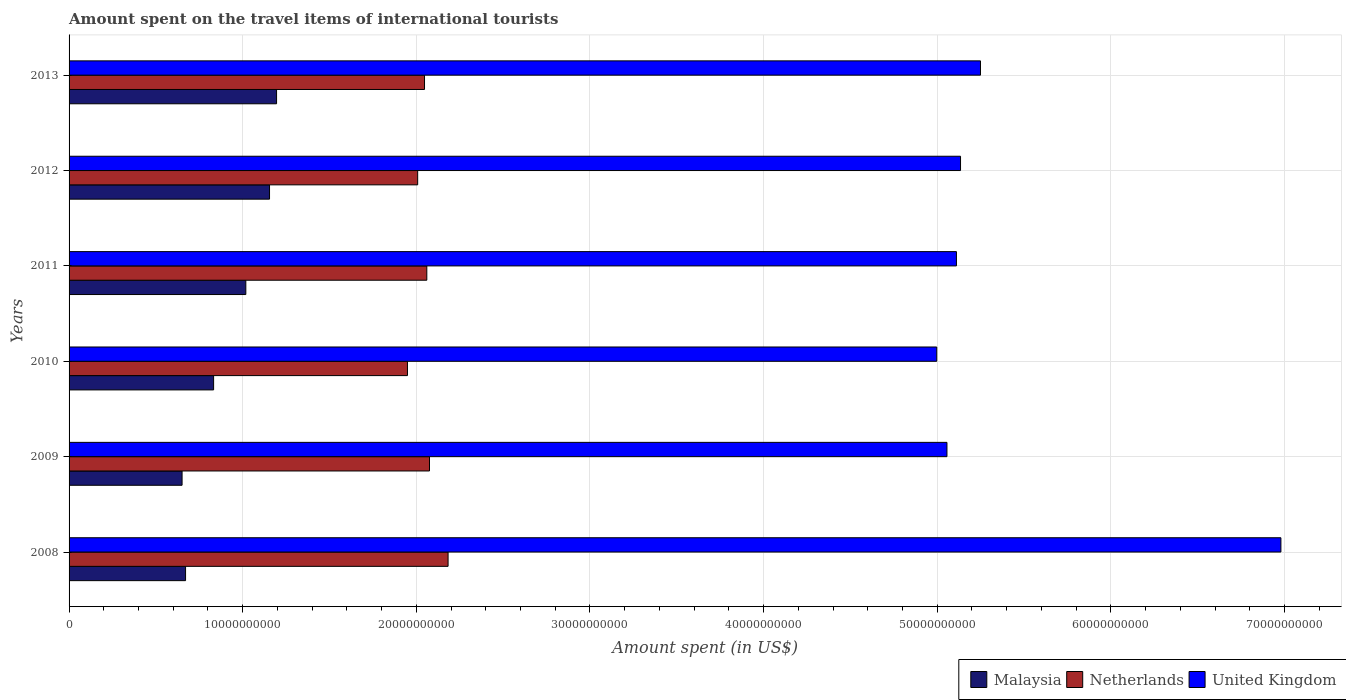How many different coloured bars are there?
Offer a terse response. 3. How many groups of bars are there?
Give a very brief answer. 6. Are the number of bars per tick equal to the number of legend labels?
Provide a succinct answer. Yes. How many bars are there on the 2nd tick from the top?
Your answer should be compact. 3. How many bars are there on the 2nd tick from the bottom?
Keep it short and to the point. 3. In how many cases, is the number of bars for a given year not equal to the number of legend labels?
Your response must be concise. 0. What is the amount spent on the travel items of international tourists in United Kingdom in 2010?
Provide a short and direct response. 5.00e+1. Across all years, what is the maximum amount spent on the travel items of international tourists in Netherlands?
Your response must be concise. 2.18e+1. Across all years, what is the minimum amount spent on the travel items of international tourists in United Kingdom?
Provide a succinct answer. 5.00e+1. What is the total amount spent on the travel items of international tourists in United Kingdom in the graph?
Provide a short and direct response. 3.25e+11. What is the difference between the amount spent on the travel items of international tourists in Netherlands in 2011 and that in 2013?
Offer a terse response. 1.32e+08. What is the difference between the amount spent on the travel items of international tourists in United Kingdom in 2011 and the amount spent on the travel items of international tourists in Netherlands in 2013?
Keep it short and to the point. 3.06e+1. What is the average amount spent on the travel items of international tourists in Netherlands per year?
Keep it short and to the point. 2.05e+1. In the year 2008, what is the difference between the amount spent on the travel items of international tourists in Netherlands and amount spent on the travel items of international tourists in United Kingdom?
Provide a short and direct response. -4.80e+1. What is the ratio of the amount spent on the travel items of international tourists in Malaysia in 2008 to that in 2010?
Your answer should be very brief. 0.81. What is the difference between the highest and the second highest amount spent on the travel items of international tourists in Malaysia?
Provide a short and direct response. 4.05e+08. What is the difference between the highest and the lowest amount spent on the travel items of international tourists in United Kingdom?
Ensure brevity in your answer.  1.98e+1. Is the sum of the amount spent on the travel items of international tourists in United Kingdom in 2009 and 2010 greater than the maximum amount spent on the travel items of international tourists in Malaysia across all years?
Ensure brevity in your answer.  Yes. How many bars are there?
Provide a succinct answer. 18. Does the graph contain any zero values?
Ensure brevity in your answer.  No. What is the title of the graph?
Your answer should be very brief. Amount spent on the travel items of international tourists. Does "Botswana" appear as one of the legend labels in the graph?
Provide a short and direct response. No. What is the label or title of the X-axis?
Your response must be concise. Amount spent (in US$). What is the Amount spent (in US$) of Malaysia in 2008?
Offer a very short reply. 6.71e+09. What is the Amount spent (in US$) of Netherlands in 2008?
Offer a very short reply. 2.18e+1. What is the Amount spent (in US$) in United Kingdom in 2008?
Make the answer very short. 6.98e+1. What is the Amount spent (in US$) of Malaysia in 2009?
Ensure brevity in your answer.  6.51e+09. What is the Amount spent (in US$) in Netherlands in 2009?
Ensure brevity in your answer.  2.08e+1. What is the Amount spent (in US$) of United Kingdom in 2009?
Give a very brief answer. 5.06e+1. What is the Amount spent (in US$) of Malaysia in 2010?
Your answer should be compact. 8.32e+09. What is the Amount spent (in US$) of Netherlands in 2010?
Your answer should be compact. 1.95e+1. What is the Amount spent (in US$) of United Kingdom in 2010?
Provide a succinct answer. 5.00e+1. What is the Amount spent (in US$) in Malaysia in 2011?
Ensure brevity in your answer.  1.02e+1. What is the Amount spent (in US$) in Netherlands in 2011?
Your response must be concise. 2.06e+1. What is the Amount spent (in US$) of United Kingdom in 2011?
Your response must be concise. 5.11e+1. What is the Amount spent (in US$) of Malaysia in 2012?
Give a very brief answer. 1.15e+1. What is the Amount spent (in US$) of Netherlands in 2012?
Your response must be concise. 2.01e+1. What is the Amount spent (in US$) of United Kingdom in 2012?
Offer a terse response. 5.13e+1. What is the Amount spent (in US$) of Malaysia in 2013?
Offer a terse response. 1.20e+1. What is the Amount spent (in US$) in Netherlands in 2013?
Ensure brevity in your answer.  2.05e+1. What is the Amount spent (in US$) in United Kingdom in 2013?
Offer a terse response. 5.25e+1. Across all years, what is the maximum Amount spent (in US$) in Malaysia?
Your answer should be very brief. 1.20e+1. Across all years, what is the maximum Amount spent (in US$) of Netherlands?
Your response must be concise. 2.18e+1. Across all years, what is the maximum Amount spent (in US$) of United Kingdom?
Your answer should be very brief. 6.98e+1. Across all years, what is the minimum Amount spent (in US$) in Malaysia?
Give a very brief answer. 6.51e+09. Across all years, what is the minimum Amount spent (in US$) in Netherlands?
Offer a very short reply. 1.95e+1. Across all years, what is the minimum Amount spent (in US$) in United Kingdom?
Your response must be concise. 5.00e+1. What is the total Amount spent (in US$) in Malaysia in the graph?
Offer a very short reply. 5.52e+1. What is the total Amount spent (in US$) of Netherlands in the graph?
Your answer should be compact. 1.23e+11. What is the total Amount spent (in US$) of United Kingdom in the graph?
Keep it short and to the point. 3.25e+11. What is the difference between the Amount spent (in US$) in Malaysia in 2008 and that in 2009?
Your answer should be compact. 2.01e+08. What is the difference between the Amount spent (in US$) of Netherlands in 2008 and that in 2009?
Provide a succinct answer. 1.07e+09. What is the difference between the Amount spent (in US$) in United Kingdom in 2008 and that in 2009?
Provide a short and direct response. 1.92e+1. What is the difference between the Amount spent (in US$) in Malaysia in 2008 and that in 2010?
Offer a terse response. -1.62e+09. What is the difference between the Amount spent (in US$) of Netherlands in 2008 and that in 2010?
Keep it short and to the point. 2.34e+09. What is the difference between the Amount spent (in US$) in United Kingdom in 2008 and that in 2010?
Provide a succinct answer. 1.98e+1. What is the difference between the Amount spent (in US$) in Malaysia in 2008 and that in 2011?
Offer a terse response. -3.47e+09. What is the difference between the Amount spent (in US$) of Netherlands in 2008 and that in 2011?
Give a very brief answer. 1.22e+09. What is the difference between the Amount spent (in US$) of United Kingdom in 2008 and that in 2011?
Give a very brief answer. 1.87e+1. What is the difference between the Amount spent (in US$) of Malaysia in 2008 and that in 2012?
Offer a very short reply. -4.84e+09. What is the difference between the Amount spent (in US$) in Netherlands in 2008 and that in 2012?
Offer a terse response. 1.75e+09. What is the difference between the Amount spent (in US$) of United Kingdom in 2008 and that in 2012?
Keep it short and to the point. 1.85e+1. What is the difference between the Amount spent (in US$) in Malaysia in 2008 and that in 2013?
Keep it short and to the point. -5.24e+09. What is the difference between the Amount spent (in US$) in Netherlands in 2008 and that in 2013?
Make the answer very short. 1.36e+09. What is the difference between the Amount spent (in US$) of United Kingdom in 2008 and that in 2013?
Offer a very short reply. 1.73e+1. What is the difference between the Amount spent (in US$) in Malaysia in 2009 and that in 2010?
Ensure brevity in your answer.  -1.82e+09. What is the difference between the Amount spent (in US$) of Netherlands in 2009 and that in 2010?
Provide a succinct answer. 1.27e+09. What is the difference between the Amount spent (in US$) in United Kingdom in 2009 and that in 2010?
Ensure brevity in your answer.  5.87e+08. What is the difference between the Amount spent (in US$) in Malaysia in 2009 and that in 2011?
Give a very brief answer. -3.67e+09. What is the difference between the Amount spent (in US$) of Netherlands in 2009 and that in 2011?
Offer a terse response. 1.55e+08. What is the difference between the Amount spent (in US$) of United Kingdom in 2009 and that in 2011?
Provide a short and direct response. -5.46e+08. What is the difference between the Amount spent (in US$) of Malaysia in 2009 and that in 2012?
Your answer should be very brief. -5.04e+09. What is the difference between the Amount spent (in US$) in Netherlands in 2009 and that in 2012?
Provide a succinct answer. 6.81e+08. What is the difference between the Amount spent (in US$) of United Kingdom in 2009 and that in 2012?
Provide a short and direct response. -7.82e+08. What is the difference between the Amount spent (in US$) of Malaysia in 2009 and that in 2013?
Your answer should be compact. -5.44e+09. What is the difference between the Amount spent (in US$) in Netherlands in 2009 and that in 2013?
Provide a short and direct response. 2.87e+08. What is the difference between the Amount spent (in US$) of United Kingdom in 2009 and that in 2013?
Your answer should be compact. -1.93e+09. What is the difference between the Amount spent (in US$) in Malaysia in 2010 and that in 2011?
Make the answer very short. -1.86e+09. What is the difference between the Amount spent (in US$) in Netherlands in 2010 and that in 2011?
Ensure brevity in your answer.  -1.11e+09. What is the difference between the Amount spent (in US$) in United Kingdom in 2010 and that in 2011?
Provide a short and direct response. -1.13e+09. What is the difference between the Amount spent (in US$) of Malaysia in 2010 and that in 2012?
Give a very brief answer. -3.22e+09. What is the difference between the Amount spent (in US$) in Netherlands in 2010 and that in 2012?
Your answer should be very brief. -5.88e+08. What is the difference between the Amount spent (in US$) of United Kingdom in 2010 and that in 2012?
Your answer should be compact. -1.37e+09. What is the difference between the Amount spent (in US$) in Malaysia in 2010 and that in 2013?
Give a very brief answer. -3.63e+09. What is the difference between the Amount spent (in US$) of Netherlands in 2010 and that in 2013?
Make the answer very short. -9.82e+08. What is the difference between the Amount spent (in US$) in United Kingdom in 2010 and that in 2013?
Make the answer very short. -2.52e+09. What is the difference between the Amount spent (in US$) in Malaysia in 2011 and that in 2012?
Provide a succinct answer. -1.36e+09. What is the difference between the Amount spent (in US$) of Netherlands in 2011 and that in 2012?
Provide a succinct answer. 5.26e+08. What is the difference between the Amount spent (in US$) of United Kingdom in 2011 and that in 2012?
Make the answer very short. -2.36e+08. What is the difference between the Amount spent (in US$) in Malaysia in 2011 and that in 2013?
Provide a succinct answer. -1.77e+09. What is the difference between the Amount spent (in US$) of Netherlands in 2011 and that in 2013?
Ensure brevity in your answer.  1.32e+08. What is the difference between the Amount spent (in US$) in United Kingdom in 2011 and that in 2013?
Your response must be concise. -1.38e+09. What is the difference between the Amount spent (in US$) in Malaysia in 2012 and that in 2013?
Keep it short and to the point. -4.05e+08. What is the difference between the Amount spent (in US$) in Netherlands in 2012 and that in 2013?
Offer a terse response. -3.94e+08. What is the difference between the Amount spent (in US$) in United Kingdom in 2012 and that in 2013?
Offer a very short reply. -1.15e+09. What is the difference between the Amount spent (in US$) of Malaysia in 2008 and the Amount spent (in US$) of Netherlands in 2009?
Ensure brevity in your answer.  -1.40e+1. What is the difference between the Amount spent (in US$) in Malaysia in 2008 and the Amount spent (in US$) in United Kingdom in 2009?
Offer a very short reply. -4.38e+1. What is the difference between the Amount spent (in US$) in Netherlands in 2008 and the Amount spent (in US$) in United Kingdom in 2009?
Give a very brief answer. -2.87e+1. What is the difference between the Amount spent (in US$) of Malaysia in 2008 and the Amount spent (in US$) of Netherlands in 2010?
Make the answer very short. -1.28e+1. What is the difference between the Amount spent (in US$) in Malaysia in 2008 and the Amount spent (in US$) in United Kingdom in 2010?
Your response must be concise. -4.33e+1. What is the difference between the Amount spent (in US$) of Netherlands in 2008 and the Amount spent (in US$) of United Kingdom in 2010?
Ensure brevity in your answer.  -2.81e+1. What is the difference between the Amount spent (in US$) of Malaysia in 2008 and the Amount spent (in US$) of Netherlands in 2011?
Your answer should be compact. -1.39e+1. What is the difference between the Amount spent (in US$) of Malaysia in 2008 and the Amount spent (in US$) of United Kingdom in 2011?
Your answer should be very brief. -4.44e+1. What is the difference between the Amount spent (in US$) of Netherlands in 2008 and the Amount spent (in US$) of United Kingdom in 2011?
Your answer should be compact. -2.93e+1. What is the difference between the Amount spent (in US$) of Malaysia in 2008 and the Amount spent (in US$) of Netherlands in 2012?
Your answer should be compact. -1.34e+1. What is the difference between the Amount spent (in US$) in Malaysia in 2008 and the Amount spent (in US$) in United Kingdom in 2012?
Make the answer very short. -4.46e+1. What is the difference between the Amount spent (in US$) in Netherlands in 2008 and the Amount spent (in US$) in United Kingdom in 2012?
Offer a very short reply. -2.95e+1. What is the difference between the Amount spent (in US$) of Malaysia in 2008 and the Amount spent (in US$) of Netherlands in 2013?
Your answer should be very brief. -1.38e+1. What is the difference between the Amount spent (in US$) in Malaysia in 2008 and the Amount spent (in US$) in United Kingdom in 2013?
Give a very brief answer. -4.58e+1. What is the difference between the Amount spent (in US$) in Netherlands in 2008 and the Amount spent (in US$) in United Kingdom in 2013?
Offer a very short reply. -3.07e+1. What is the difference between the Amount spent (in US$) of Malaysia in 2009 and the Amount spent (in US$) of Netherlands in 2010?
Offer a terse response. -1.30e+1. What is the difference between the Amount spent (in US$) in Malaysia in 2009 and the Amount spent (in US$) in United Kingdom in 2010?
Provide a short and direct response. -4.35e+1. What is the difference between the Amount spent (in US$) in Netherlands in 2009 and the Amount spent (in US$) in United Kingdom in 2010?
Offer a very short reply. -2.92e+1. What is the difference between the Amount spent (in US$) in Malaysia in 2009 and the Amount spent (in US$) in Netherlands in 2011?
Give a very brief answer. -1.41e+1. What is the difference between the Amount spent (in US$) of Malaysia in 2009 and the Amount spent (in US$) of United Kingdom in 2011?
Your answer should be very brief. -4.46e+1. What is the difference between the Amount spent (in US$) of Netherlands in 2009 and the Amount spent (in US$) of United Kingdom in 2011?
Your answer should be compact. -3.03e+1. What is the difference between the Amount spent (in US$) of Malaysia in 2009 and the Amount spent (in US$) of Netherlands in 2012?
Offer a very short reply. -1.36e+1. What is the difference between the Amount spent (in US$) of Malaysia in 2009 and the Amount spent (in US$) of United Kingdom in 2012?
Ensure brevity in your answer.  -4.48e+1. What is the difference between the Amount spent (in US$) in Netherlands in 2009 and the Amount spent (in US$) in United Kingdom in 2012?
Offer a very short reply. -3.06e+1. What is the difference between the Amount spent (in US$) of Malaysia in 2009 and the Amount spent (in US$) of Netherlands in 2013?
Your answer should be compact. -1.40e+1. What is the difference between the Amount spent (in US$) in Malaysia in 2009 and the Amount spent (in US$) in United Kingdom in 2013?
Your answer should be very brief. -4.60e+1. What is the difference between the Amount spent (in US$) in Netherlands in 2009 and the Amount spent (in US$) in United Kingdom in 2013?
Your response must be concise. -3.17e+1. What is the difference between the Amount spent (in US$) in Malaysia in 2010 and the Amount spent (in US$) in Netherlands in 2011?
Keep it short and to the point. -1.23e+1. What is the difference between the Amount spent (in US$) in Malaysia in 2010 and the Amount spent (in US$) in United Kingdom in 2011?
Provide a short and direct response. -4.28e+1. What is the difference between the Amount spent (in US$) of Netherlands in 2010 and the Amount spent (in US$) of United Kingdom in 2011?
Ensure brevity in your answer.  -3.16e+1. What is the difference between the Amount spent (in US$) in Malaysia in 2010 and the Amount spent (in US$) in Netherlands in 2012?
Make the answer very short. -1.18e+1. What is the difference between the Amount spent (in US$) in Malaysia in 2010 and the Amount spent (in US$) in United Kingdom in 2012?
Ensure brevity in your answer.  -4.30e+1. What is the difference between the Amount spent (in US$) in Netherlands in 2010 and the Amount spent (in US$) in United Kingdom in 2012?
Provide a short and direct response. -3.19e+1. What is the difference between the Amount spent (in US$) of Malaysia in 2010 and the Amount spent (in US$) of Netherlands in 2013?
Provide a short and direct response. -1.21e+1. What is the difference between the Amount spent (in US$) of Malaysia in 2010 and the Amount spent (in US$) of United Kingdom in 2013?
Make the answer very short. -4.42e+1. What is the difference between the Amount spent (in US$) of Netherlands in 2010 and the Amount spent (in US$) of United Kingdom in 2013?
Your response must be concise. -3.30e+1. What is the difference between the Amount spent (in US$) in Malaysia in 2011 and the Amount spent (in US$) in Netherlands in 2012?
Provide a short and direct response. -9.90e+09. What is the difference between the Amount spent (in US$) in Malaysia in 2011 and the Amount spent (in US$) in United Kingdom in 2012?
Give a very brief answer. -4.12e+1. What is the difference between the Amount spent (in US$) of Netherlands in 2011 and the Amount spent (in US$) of United Kingdom in 2012?
Keep it short and to the point. -3.07e+1. What is the difference between the Amount spent (in US$) of Malaysia in 2011 and the Amount spent (in US$) of Netherlands in 2013?
Offer a terse response. -1.03e+1. What is the difference between the Amount spent (in US$) in Malaysia in 2011 and the Amount spent (in US$) in United Kingdom in 2013?
Your answer should be compact. -4.23e+1. What is the difference between the Amount spent (in US$) of Netherlands in 2011 and the Amount spent (in US$) of United Kingdom in 2013?
Provide a succinct answer. -3.19e+1. What is the difference between the Amount spent (in US$) in Malaysia in 2012 and the Amount spent (in US$) in Netherlands in 2013?
Ensure brevity in your answer.  -8.93e+09. What is the difference between the Amount spent (in US$) in Malaysia in 2012 and the Amount spent (in US$) in United Kingdom in 2013?
Your response must be concise. -4.09e+1. What is the difference between the Amount spent (in US$) of Netherlands in 2012 and the Amount spent (in US$) of United Kingdom in 2013?
Your answer should be very brief. -3.24e+1. What is the average Amount spent (in US$) of Malaysia per year?
Keep it short and to the point. 9.20e+09. What is the average Amount spent (in US$) in Netherlands per year?
Give a very brief answer. 2.05e+1. What is the average Amount spent (in US$) in United Kingdom per year?
Give a very brief answer. 5.42e+1. In the year 2008, what is the difference between the Amount spent (in US$) in Malaysia and Amount spent (in US$) in Netherlands?
Make the answer very short. -1.51e+1. In the year 2008, what is the difference between the Amount spent (in US$) in Malaysia and Amount spent (in US$) in United Kingdom?
Offer a very short reply. -6.31e+1. In the year 2008, what is the difference between the Amount spent (in US$) of Netherlands and Amount spent (in US$) of United Kingdom?
Make the answer very short. -4.80e+1. In the year 2009, what is the difference between the Amount spent (in US$) in Malaysia and Amount spent (in US$) in Netherlands?
Give a very brief answer. -1.42e+1. In the year 2009, what is the difference between the Amount spent (in US$) of Malaysia and Amount spent (in US$) of United Kingdom?
Ensure brevity in your answer.  -4.41e+1. In the year 2009, what is the difference between the Amount spent (in US$) in Netherlands and Amount spent (in US$) in United Kingdom?
Give a very brief answer. -2.98e+1. In the year 2010, what is the difference between the Amount spent (in US$) of Malaysia and Amount spent (in US$) of Netherlands?
Your answer should be very brief. -1.12e+1. In the year 2010, what is the difference between the Amount spent (in US$) in Malaysia and Amount spent (in US$) in United Kingdom?
Offer a terse response. -4.16e+1. In the year 2010, what is the difference between the Amount spent (in US$) of Netherlands and Amount spent (in US$) of United Kingdom?
Your response must be concise. -3.05e+1. In the year 2011, what is the difference between the Amount spent (in US$) in Malaysia and Amount spent (in US$) in Netherlands?
Provide a succinct answer. -1.04e+1. In the year 2011, what is the difference between the Amount spent (in US$) of Malaysia and Amount spent (in US$) of United Kingdom?
Provide a short and direct response. -4.09e+1. In the year 2011, what is the difference between the Amount spent (in US$) in Netherlands and Amount spent (in US$) in United Kingdom?
Offer a terse response. -3.05e+1. In the year 2012, what is the difference between the Amount spent (in US$) in Malaysia and Amount spent (in US$) in Netherlands?
Keep it short and to the point. -8.53e+09. In the year 2012, what is the difference between the Amount spent (in US$) of Malaysia and Amount spent (in US$) of United Kingdom?
Your answer should be compact. -3.98e+1. In the year 2012, what is the difference between the Amount spent (in US$) of Netherlands and Amount spent (in US$) of United Kingdom?
Give a very brief answer. -3.13e+1. In the year 2013, what is the difference between the Amount spent (in US$) of Malaysia and Amount spent (in US$) of Netherlands?
Offer a terse response. -8.52e+09. In the year 2013, what is the difference between the Amount spent (in US$) of Malaysia and Amount spent (in US$) of United Kingdom?
Your response must be concise. -4.05e+1. In the year 2013, what is the difference between the Amount spent (in US$) in Netherlands and Amount spent (in US$) in United Kingdom?
Keep it short and to the point. -3.20e+1. What is the ratio of the Amount spent (in US$) of Malaysia in 2008 to that in 2009?
Your answer should be compact. 1.03. What is the ratio of the Amount spent (in US$) of Netherlands in 2008 to that in 2009?
Provide a short and direct response. 1.05. What is the ratio of the Amount spent (in US$) in United Kingdom in 2008 to that in 2009?
Your answer should be compact. 1.38. What is the ratio of the Amount spent (in US$) of Malaysia in 2008 to that in 2010?
Provide a succinct answer. 0.81. What is the ratio of the Amount spent (in US$) in Netherlands in 2008 to that in 2010?
Provide a short and direct response. 1.12. What is the ratio of the Amount spent (in US$) in United Kingdom in 2008 to that in 2010?
Offer a terse response. 1.4. What is the ratio of the Amount spent (in US$) in Malaysia in 2008 to that in 2011?
Give a very brief answer. 0.66. What is the ratio of the Amount spent (in US$) of Netherlands in 2008 to that in 2011?
Your answer should be very brief. 1.06. What is the ratio of the Amount spent (in US$) in United Kingdom in 2008 to that in 2011?
Offer a very short reply. 1.37. What is the ratio of the Amount spent (in US$) in Malaysia in 2008 to that in 2012?
Offer a very short reply. 0.58. What is the ratio of the Amount spent (in US$) of Netherlands in 2008 to that in 2012?
Ensure brevity in your answer.  1.09. What is the ratio of the Amount spent (in US$) in United Kingdom in 2008 to that in 2012?
Your response must be concise. 1.36. What is the ratio of the Amount spent (in US$) in Malaysia in 2008 to that in 2013?
Keep it short and to the point. 0.56. What is the ratio of the Amount spent (in US$) in Netherlands in 2008 to that in 2013?
Offer a terse response. 1.07. What is the ratio of the Amount spent (in US$) of United Kingdom in 2008 to that in 2013?
Ensure brevity in your answer.  1.33. What is the ratio of the Amount spent (in US$) of Malaysia in 2009 to that in 2010?
Provide a succinct answer. 0.78. What is the ratio of the Amount spent (in US$) of Netherlands in 2009 to that in 2010?
Offer a very short reply. 1.07. What is the ratio of the Amount spent (in US$) in United Kingdom in 2009 to that in 2010?
Your response must be concise. 1.01. What is the ratio of the Amount spent (in US$) in Malaysia in 2009 to that in 2011?
Keep it short and to the point. 0.64. What is the ratio of the Amount spent (in US$) of Netherlands in 2009 to that in 2011?
Make the answer very short. 1.01. What is the ratio of the Amount spent (in US$) of United Kingdom in 2009 to that in 2011?
Provide a succinct answer. 0.99. What is the ratio of the Amount spent (in US$) of Malaysia in 2009 to that in 2012?
Offer a terse response. 0.56. What is the ratio of the Amount spent (in US$) of Netherlands in 2009 to that in 2012?
Provide a short and direct response. 1.03. What is the ratio of the Amount spent (in US$) of Malaysia in 2009 to that in 2013?
Keep it short and to the point. 0.54. What is the ratio of the Amount spent (in US$) in Netherlands in 2009 to that in 2013?
Your answer should be compact. 1.01. What is the ratio of the Amount spent (in US$) in United Kingdom in 2009 to that in 2013?
Provide a succinct answer. 0.96. What is the ratio of the Amount spent (in US$) of Malaysia in 2010 to that in 2011?
Provide a succinct answer. 0.82. What is the ratio of the Amount spent (in US$) of Netherlands in 2010 to that in 2011?
Offer a terse response. 0.95. What is the ratio of the Amount spent (in US$) in United Kingdom in 2010 to that in 2011?
Your answer should be compact. 0.98. What is the ratio of the Amount spent (in US$) in Malaysia in 2010 to that in 2012?
Offer a very short reply. 0.72. What is the ratio of the Amount spent (in US$) of Netherlands in 2010 to that in 2012?
Keep it short and to the point. 0.97. What is the ratio of the Amount spent (in US$) of United Kingdom in 2010 to that in 2012?
Make the answer very short. 0.97. What is the ratio of the Amount spent (in US$) in Malaysia in 2010 to that in 2013?
Your answer should be very brief. 0.7. What is the ratio of the Amount spent (in US$) in Netherlands in 2010 to that in 2013?
Provide a succinct answer. 0.95. What is the ratio of the Amount spent (in US$) in United Kingdom in 2010 to that in 2013?
Ensure brevity in your answer.  0.95. What is the ratio of the Amount spent (in US$) of Malaysia in 2011 to that in 2012?
Offer a very short reply. 0.88. What is the ratio of the Amount spent (in US$) in Netherlands in 2011 to that in 2012?
Provide a succinct answer. 1.03. What is the ratio of the Amount spent (in US$) of Malaysia in 2011 to that in 2013?
Provide a short and direct response. 0.85. What is the ratio of the Amount spent (in US$) of Netherlands in 2011 to that in 2013?
Your answer should be very brief. 1.01. What is the ratio of the Amount spent (in US$) in United Kingdom in 2011 to that in 2013?
Ensure brevity in your answer.  0.97. What is the ratio of the Amount spent (in US$) of Malaysia in 2012 to that in 2013?
Keep it short and to the point. 0.97. What is the ratio of the Amount spent (in US$) of Netherlands in 2012 to that in 2013?
Your answer should be very brief. 0.98. What is the ratio of the Amount spent (in US$) of United Kingdom in 2012 to that in 2013?
Give a very brief answer. 0.98. What is the difference between the highest and the second highest Amount spent (in US$) of Malaysia?
Offer a terse response. 4.05e+08. What is the difference between the highest and the second highest Amount spent (in US$) in Netherlands?
Provide a short and direct response. 1.07e+09. What is the difference between the highest and the second highest Amount spent (in US$) of United Kingdom?
Your answer should be very brief. 1.73e+1. What is the difference between the highest and the lowest Amount spent (in US$) in Malaysia?
Offer a terse response. 5.44e+09. What is the difference between the highest and the lowest Amount spent (in US$) of Netherlands?
Offer a very short reply. 2.34e+09. What is the difference between the highest and the lowest Amount spent (in US$) in United Kingdom?
Offer a terse response. 1.98e+1. 